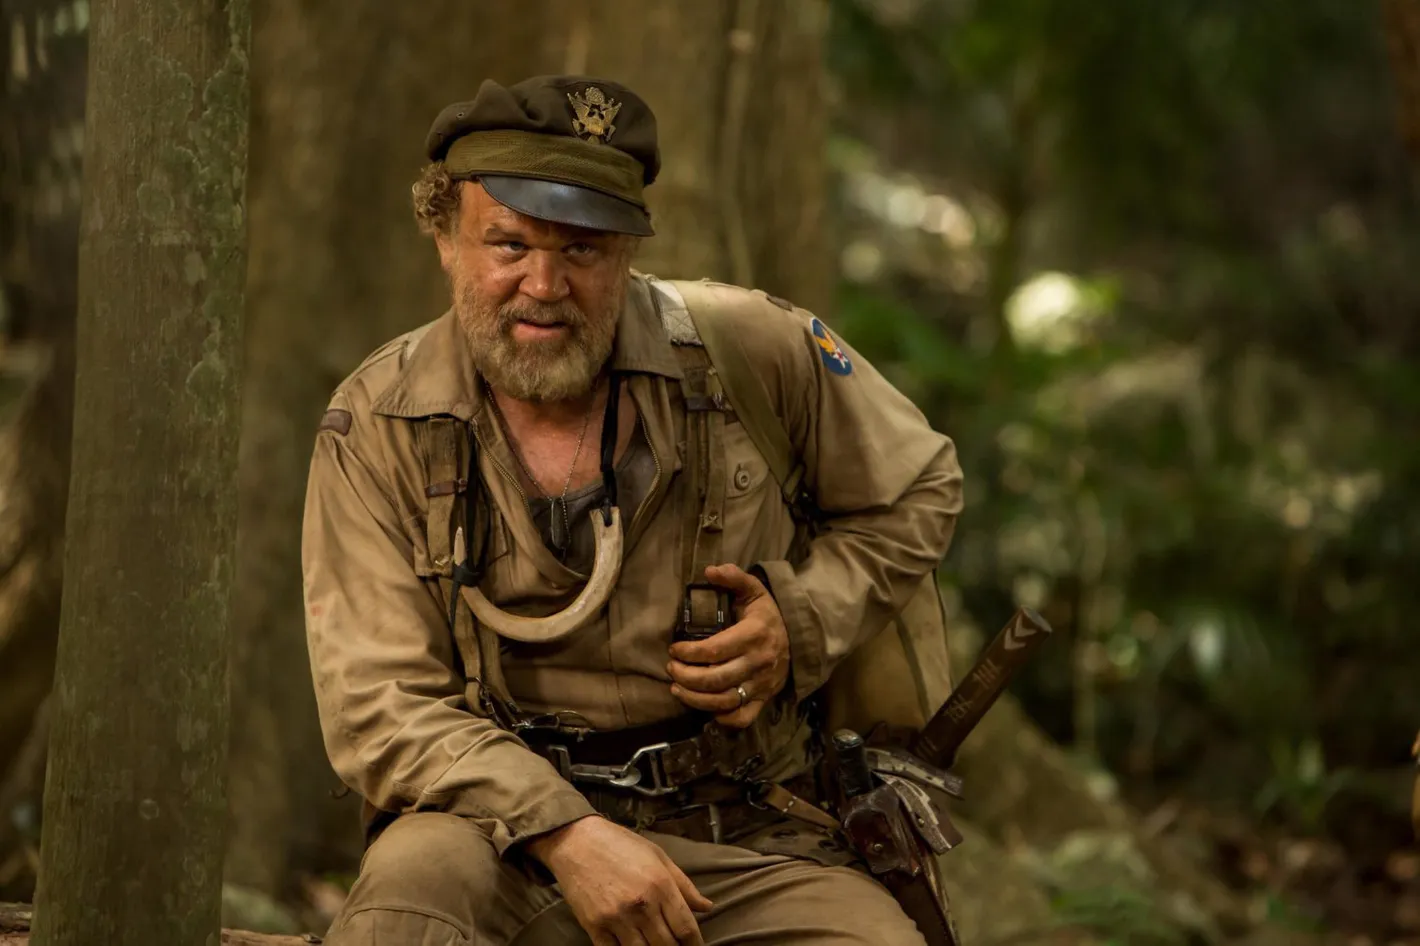Describe the following image. In this vividly detailed image, we see an experienced soldier seated on a tree stump in a dense, verdant forest. The khaki uniform he dons blends seamlessly with the surrounding foliage, suggesting an environment where blending in is essential. His hat, adorned with a distinctive badge, indicates his military affiliation, adding an air of authority to his appearance. There’s a rifle casually slung over his shoulder, making a statement about his preparedness and duty. Holding a pair of binoculars, he seems deeply engaged in surveying the landscape, perhaps scanning for any sign of movement or potential threats. His facial expression is one of resolve and focus, capturing the intense concentration and seriousness of someone committed to his mission. A closer inspection reveals additional survival gear strapped to him, indicating a readiness to face any scenario the wild might throw his way. 